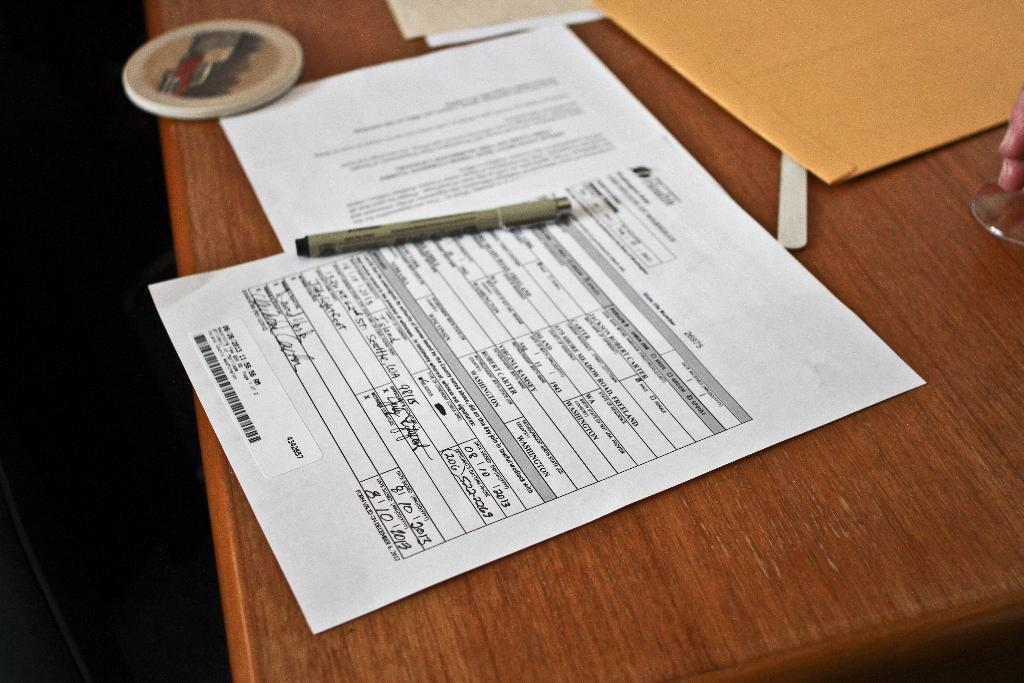What type of objects can be seen in the image? There are papers, an envelope cover, a paper weight, and a pen in the image. What might be used to hold the papers in place? The paper weight in the image can be used to hold the papers in place. What is the surface on which the objects are placed? The objects are on a wooden table. Can you describe the person's hand in the image? There is a person's hand holding a glass in the image. What year is depicted on the books in the image? There are no books present in the image; only papers, an envelope cover, a paper weight, and a pen are visible. 